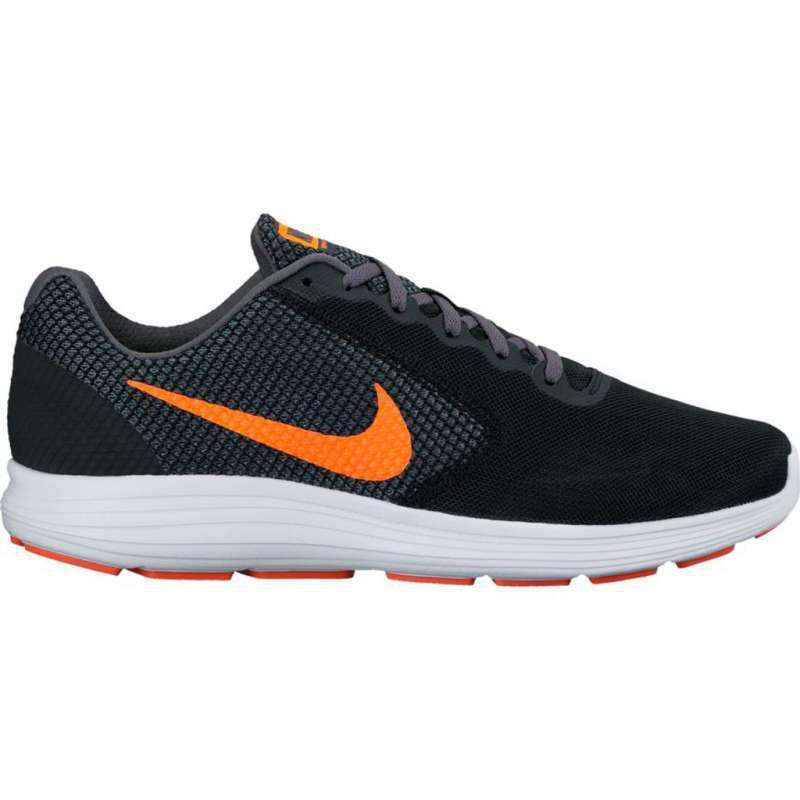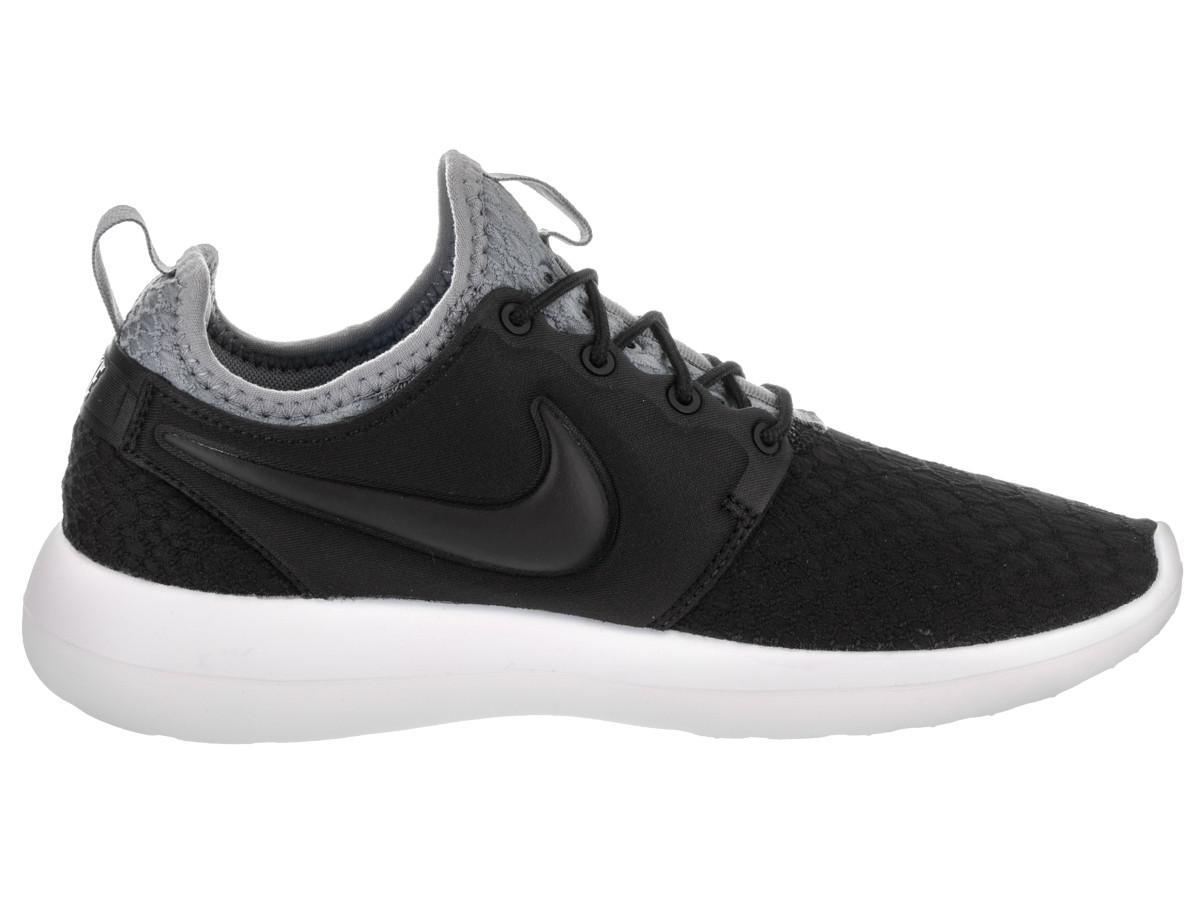The first image is the image on the left, the second image is the image on the right. Analyze the images presented: Is the assertion "Both shoes have a gray tongue." valid? Answer yes or no. No. 